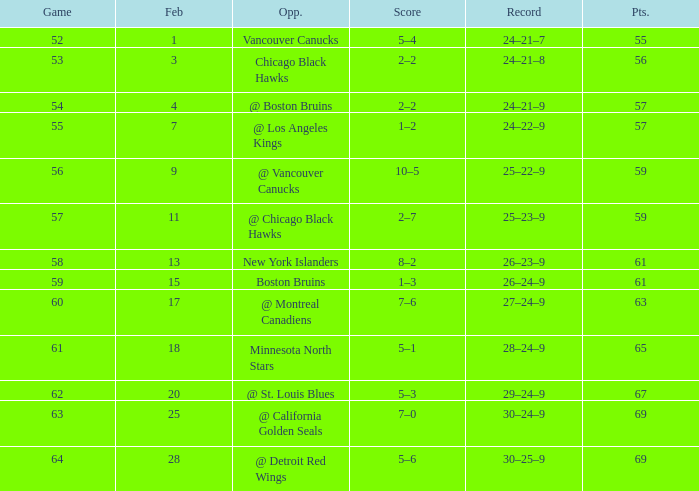How many february games had a record of 29–24–9? 20.0. 